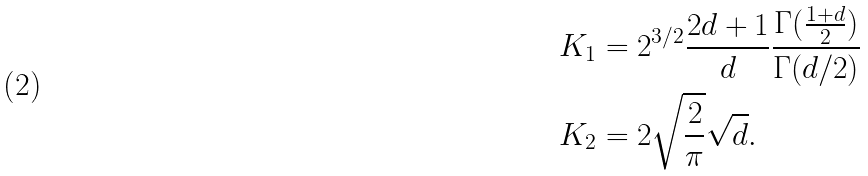<formula> <loc_0><loc_0><loc_500><loc_500>K _ { 1 } & = 2 ^ { 3 / 2 } \frac { 2 d + 1 } { d } \frac { \Gamma ( \frac { 1 + d } { 2 } ) } { \Gamma ( d / 2 ) } \\ K _ { 2 } & = 2 \sqrt { \frac { 2 } { \pi } } \sqrt { d } .</formula> 